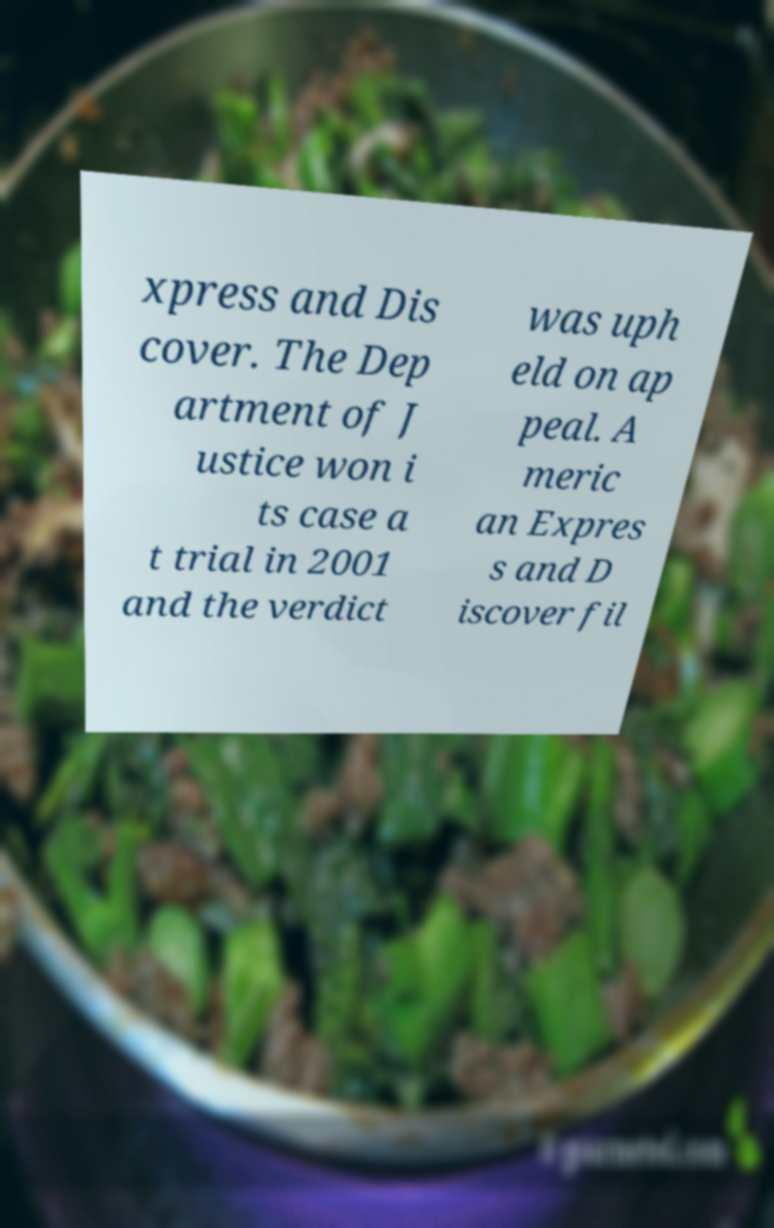Could you extract and type out the text from this image? xpress and Dis cover. The Dep artment of J ustice won i ts case a t trial in 2001 and the verdict was uph eld on ap peal. A meric an Expres s and D iscover fil 